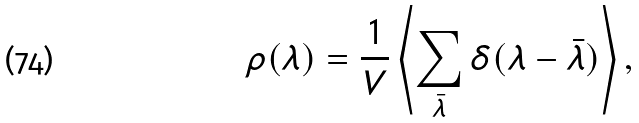<formula> <loc_0><loc_0><loc_500><loc_500>\rho ( \lambda ) = \frac { 1 } { V } \left \langle \sum _ { \bar { \lambda } } \delta ( \lambda - \bar { \lambda } ) \right \rangle ,</formula> 